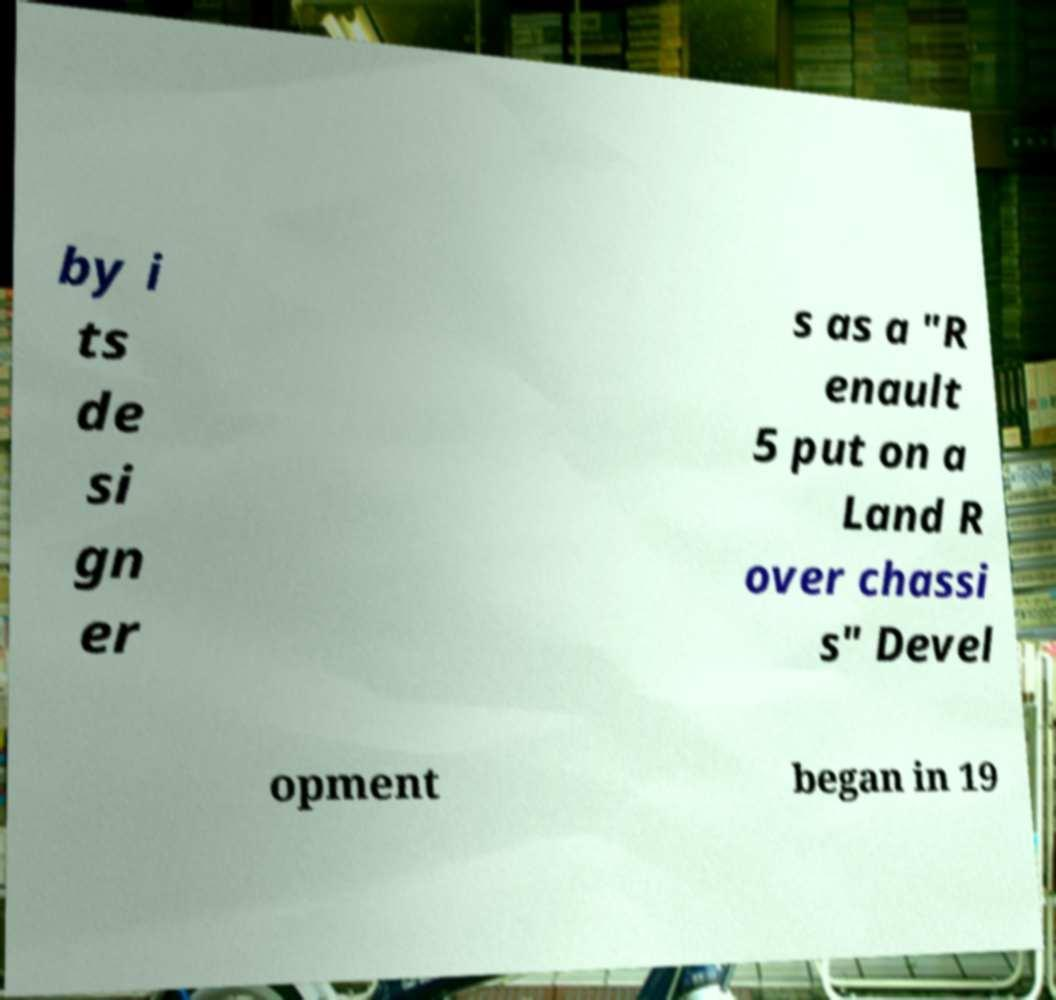Please read and relay the text visible in this image. What does it say? by i ts de si gn er s as a "R enault 5 put on a Land R over chassi s" Devel opment began in 19 